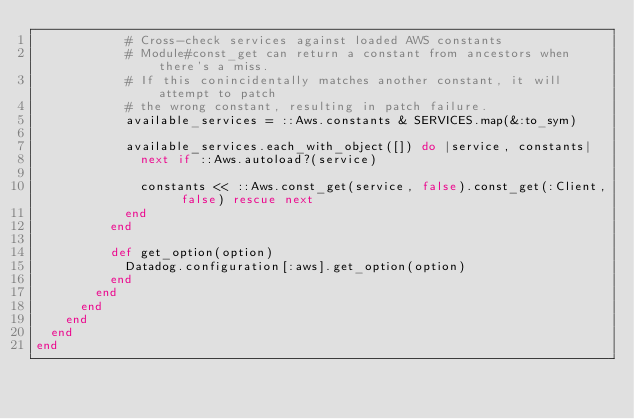Convert code to text. <code><loc_0><loc_0><loc_500><loc_500><_Ruby_>            # Cross-check services against loaded AWS constants
            # Module#const_get can return a constant from ancestors when there's a miss.
            # If this conincidentally matches another constant, it will attempt to patch
            # the wrong constant, resulting in patch failure.
            available_services = ::Aws.constants & SERVICES.map(&:to_sym)

            available_services.each_with_object([]) do |service, constants|
              next if ::Aws.autoload?(service)

              constants << ::Aws.const_get(service, false).const_get(:Client, false) rescue next
            end
          end

          def get_option(option)
            Datadog.configuration[:aws].get_option(option)
          end
        end
      end
    end
  end
end
</code> 